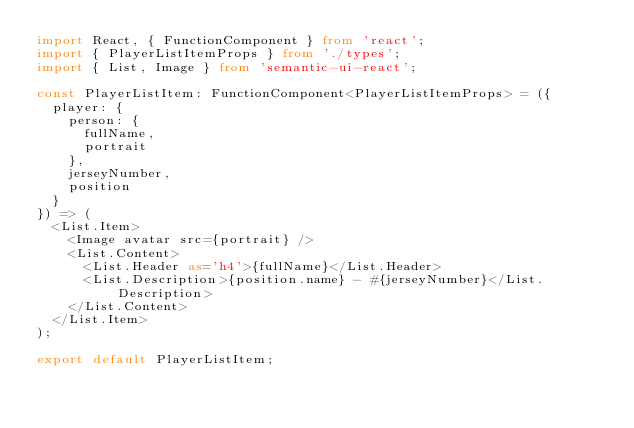<code> <loc_0><loc_0><loc_500><loc_500><_TypeScript_>import React, { FunctionComponent } from 'react';
import { PlayerListItemProps } from './types';
import { List, Image } from 'semantic-ui-react';

const PlayerListItem: FunctionComponent<PlayerListItemProps> = ({ 
  player: {
    person: {
      fullName,
      portrait
    },
    jerseyNumber,
    position
  } 
}) => (
  <List.Item>
    <Image avatar src={portrait} />
    <List.Content>
      <List.Header as='h4'>{fullName}</List.Header>
      <List.Description>{position.name} - #{jerseyNumber}</List.Description>
    </List.Content>
  </List.Item>
);

export default PlayerListItem;</code> 